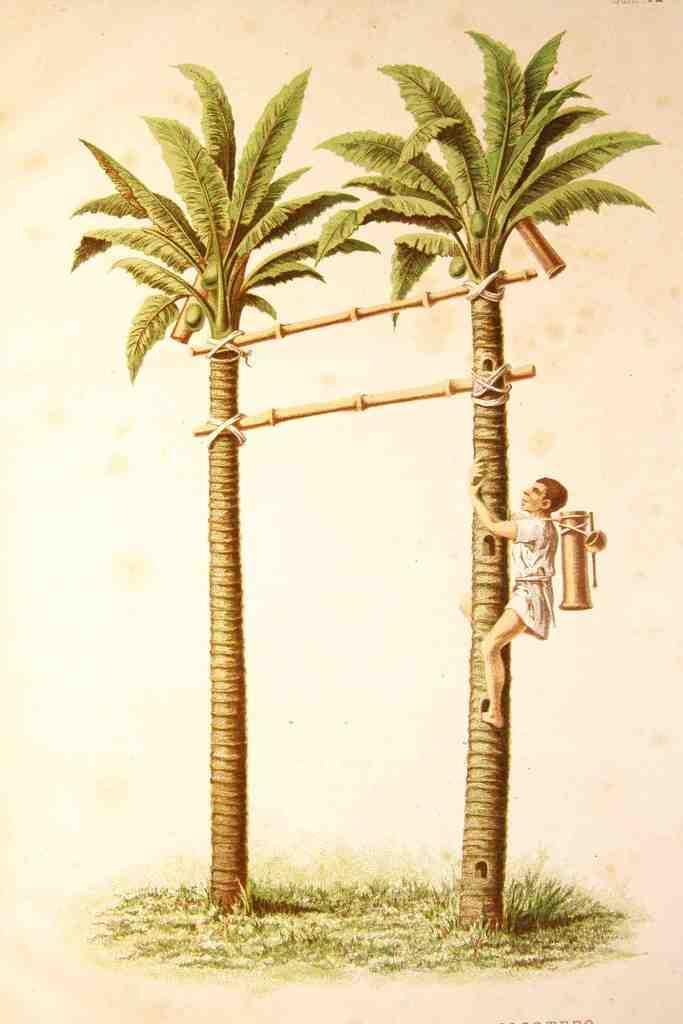Please provide a concise description of this image. In this image I can see two trees which are in green color. I can see one person on the tree and wearing the white color dress and also some object. On the ground I can see the grass. 